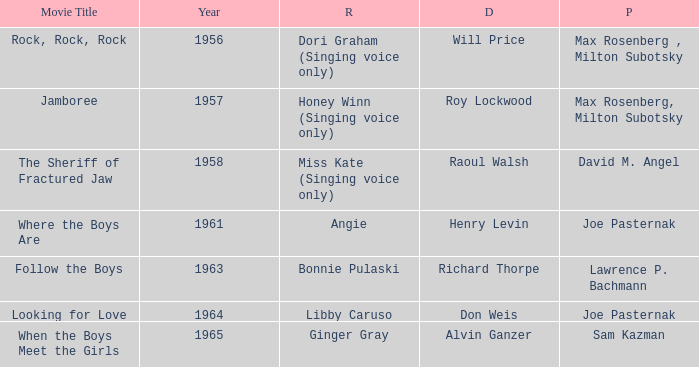What year was Sam Kazman a producer? 1965.0. 